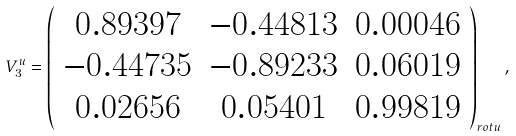Convert formula to latex. <formula><loc_0><loc_0><loc_500><loc_500>V _ { 3 } ^ { u } = \left ( \begin{array} { c c c } 0 . 8 9 3 9 7 & - 0 . 4 4 8 1 3 & 0 . 0 0 0 4 6 \\ - 0 . 4 4 7 3 5 & - 0 . 8 9 2 3 3 & 0 . 0 6 0 1 9 \\ 0 . 0 2 6 5 6 & 0 . 0 5 4 0 1 & 0 . 9 9 8 1 9 \end{array} \right ) _ { r o t u } ,</formula> 